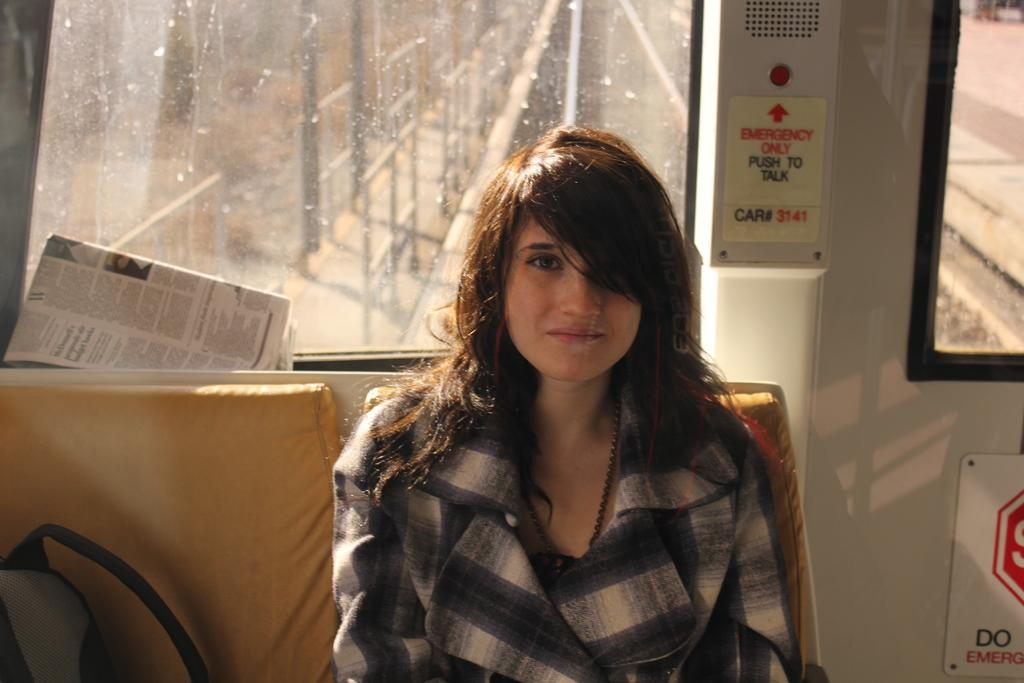What is the setting of the image? The image shows the interior of a vehicle. Who is present in the vehicle? There is a woman sitting in the vehicle. What else can be seen inside the vehicle? There are other objects visible in the vehicle. Can you describe the text-based items in the image? There are two boards with text in the image. What type of paper is the woman holding for approval in the image? There is no paper or approval process depicted in the image; it only shows the interior of a vehicle with a woman sitting inside and two boards with text. 